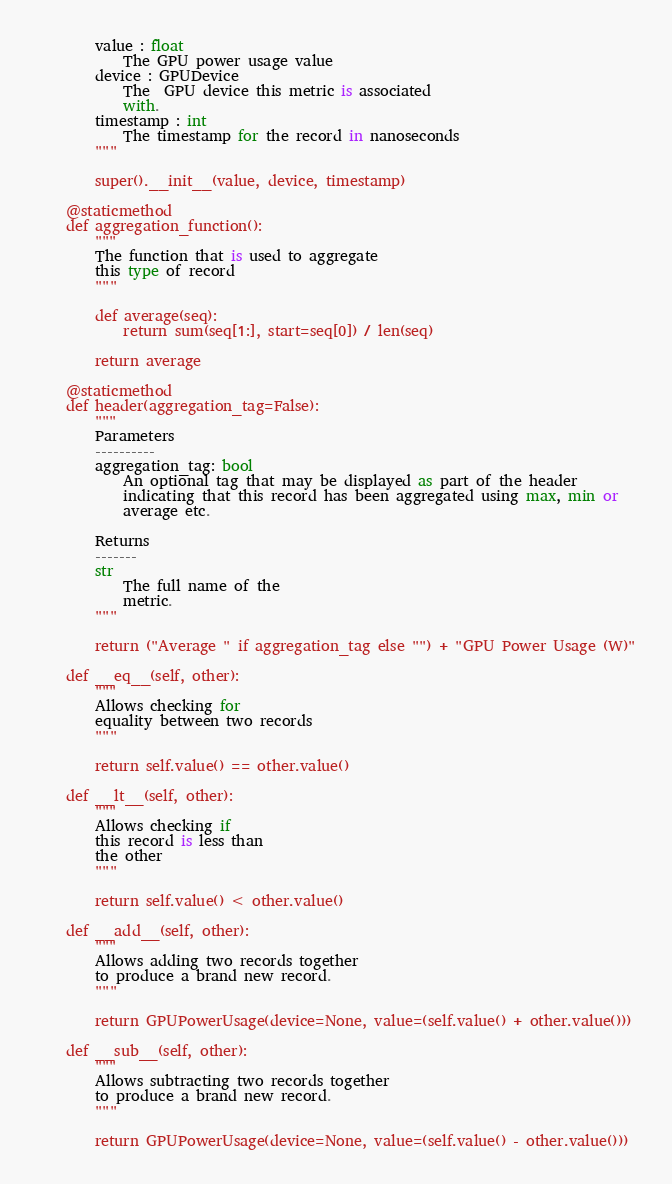<code> <loc_0><loc_0><loc_500><loc_500><_Python_>        value : float
            The GPU power usage value
        device : GPUDevice
            The  GPU device this metric is associated
            with.
        timestamp : int
            The timestamp for the record in nanoseconds
        """

        super().__init__(value, device, timestamp)

    @staticmethod
    def aggregation_function():
        """
        The function that is used to aggregate
        this type of record
        """

        def average(seq):
            return sum(seq[1:], start=seq[0]) / len(seq)

        return average

    @staticmethod
    def header(aggregation_tag=False):
        """
        Parameters
        ----------
        aggregation_tag: bool
            An optional tag that may be displayed as part of the header
            indicating that this record has been aggregated using max, min or
            average etc.

        Returns
        -------
        str
            The full name of the
            metric.
        """

        return ("Average " if aggregation_tag else "") + "GPU Power Usage (W)"

    def __eq__(self, other):
        """
        Allows checking for
        equality between two records
        """

        return self.value() == other.value()

    def __lt__(self, other):
        """
        Allows checking if
        this record is less than
        the other
        """

        return self.value() < other.value()

    def __add__(self, other):
        """
        Allows adding two records together
        to produce a brand new record.
        """

        return GPUPowerUsage(device=None, value=(self.value() + other.value()))

    def __sub__(self, other):
        """
        Allows subtracting two records together
        to produce a brand new record.
        """

        return GPUPowerUsage(device=None, value=(self.value() - other.value()))
</code> 